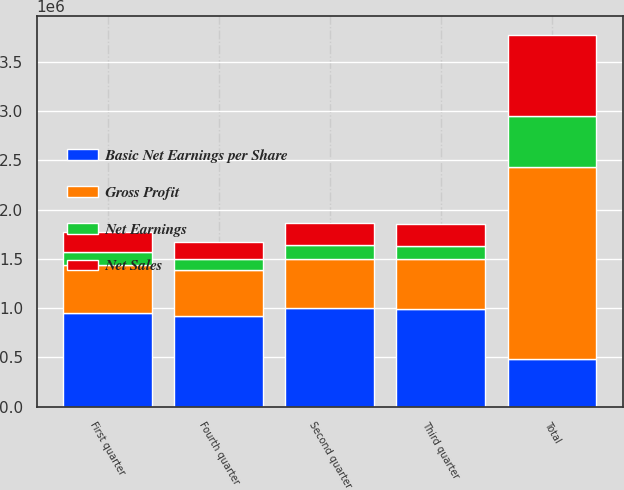Convert chart to OTSL. <chart><loc_0><loc_0><loc_500><loc_500><stacked_bar_chart><ecel><fcel>First quarter<fcel>Second quarter<fcel>Third quarter<fcel>Fourth quarter<fcel>Total<nl><fcel>Basic Net Earnings per Share<fcel>953317<fcel>997827<fcel>995250<fcel>922793<fcel>484050<nl><fcel>Gross Profit<fcel>484050<fcel>502087<fcel>502225<fcel>460572<fcel>1.94893e+06<nl><fcel>Net Sales<fcel>203512<fcel>225099<fcel>219204<fcel>178205<fcel>826020<nl><fcel>Net Earnings<fcel>127606<fcel>140357<fcel>136494<fcel>111904<fcel>516361<nl></chart> 